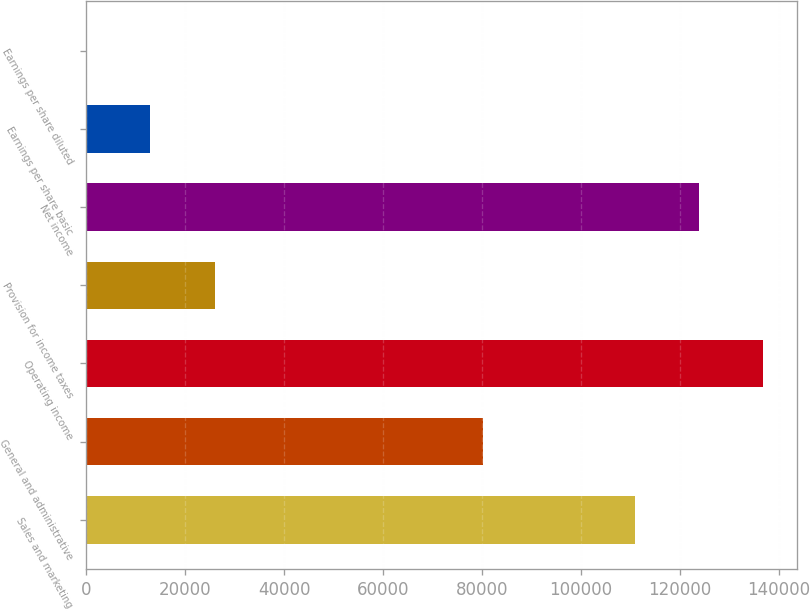Convert chart to OTSL. <chart><loc_0><loc_0><loc_500><loc_500><bar_chart><fcel>Sales and marketing<fcel>General and administrative<fcel>Operating income<fcel>Provision for income taxes<fcel>Net income<fcel>Earnings per share basic<fcel>Earnings per share diluted<nl><fcel>110846<fcel>80228<fcel>136788<fcel>25943.7<fcel>123817<fcel>12972.9<fcel>2.1<nl></chart> 